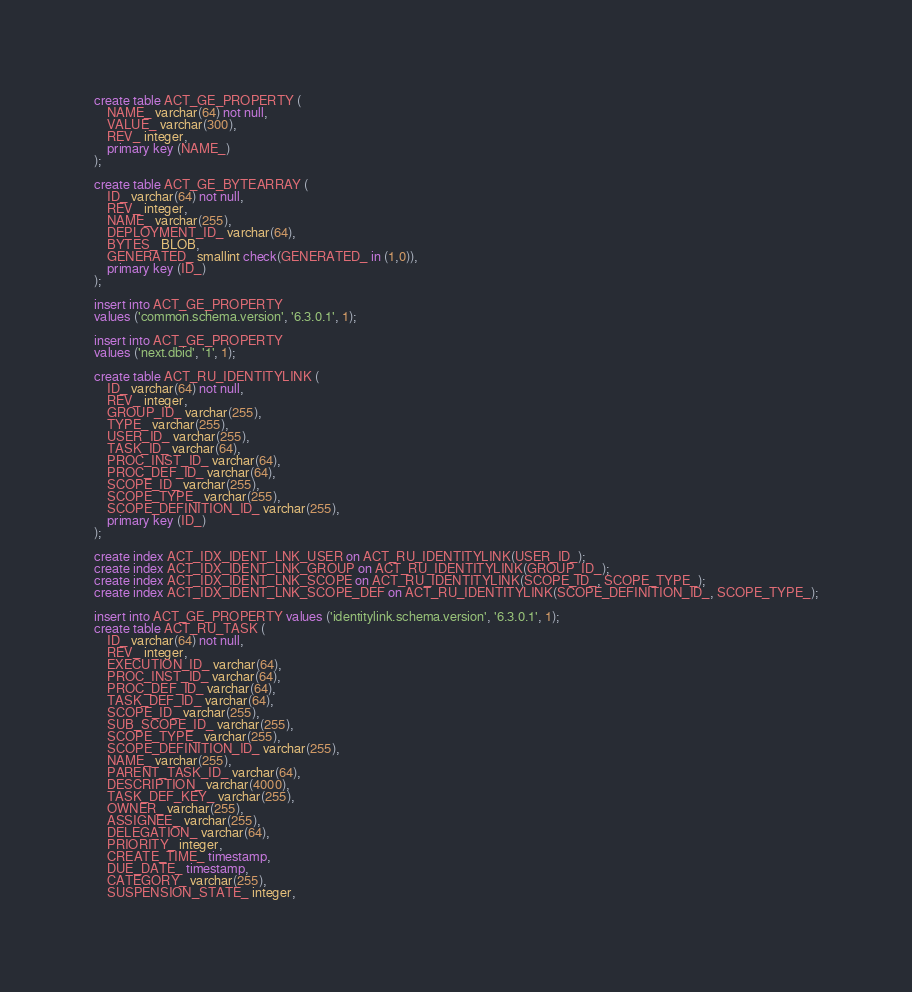Convert code to text. <code><loc_0><loc_0><loc_500><loc_500><_SQL_>create table ACT_GE_PROPERTY (
    NAME_ varchar(64) not null,
    VALUE_ varchar(300),
    REV_ integer,
    primary key (NAME_)
);

create table ACT_GE_BYTEARRAY (
    ID_ varchar(64) not null,
    REV_ integer,
    NAME_ varchar(255),
    DEPLOYMENT_ID_ varchar(64),
    BYTES_ BLOB,
    GENERATED_ smallint check(GENERATED_ in (1,0)),
    primary key (ID_)
);

insert into ACT_GE_PROPERTY
values ('common.schema.version', '6.3.0.1', 1);

insert into ACT_GE_PROPERTY
values ('next.dbid', '1', 1);

create table ACT_RU_IDENTITYLINK (
    ID_ varchar(64) not null,
    REV_ integer,
    GROUP_ID_ varchar(255),
    TYPE_ varchar(255),
    USER_ID_ varchar(255),
    TASK_ID_ varchar(64),
    PROC_INST_ID_ varchar(64),
    PROC_DEF_ID_ varchar(64),
    SCOPE_ID_ varchar(255),
    SCOPE_TYPE_ varchar(255),
    SCOPE_DEFINITION_ID_ varchar(255),
    primary key (ID_)
);

create index ACT_IDX_IDENT_LNK_USER on ACT_RU_IDENTITYLINK(USER_ID_);
create index ACT_IDX_IDENT_LNK_GROUP on ACT_RU_IDENTITYLINK(GROUP_ID_);
create index ACT_IDX_IDENT_LNK_SCOPE on ACT_RU_IDENTITYLINK(SCOPE_ID_, SCOPE_TYPE_);
create index ACT_IDX_IDENT_LNK_SCOPE_DEF on ACT_RU_IDENTITYLINK(SCOPE_DEFINITION_ID_, SCOPE_TYPE_);

insert into ACT_GE_PROPERTY values ('identitylink.schema.version', '6.3.0.1', 1);
create table ACT_RU_TASK (
    ID_ varchar(64) not null,
    REV_ integer,
    EXECUTION_ID_ varchar(64),
    PROC_INST_ID_ varchar(64),
    PROC_DEF_ID_ varchar(64),
    TASK_DEF_ID_ varchar(64),
    SCOPE_ID_ varchar(255),
    SUB_SCOPE_ID_ varchar(255),
    SCOPE_TYPE_ varchar(255),
    SCOPE_DEFINITION_ID_ varchar(255),
    NAME_ varchar(255),
    PARENT_TASK_ID_ varchar(64),
    DESCRIPTION_ varchar(4000),
    TASK_DEF_KEY_ varchar(255),
    OWNER_ varchar(255),
    ASSIGNEE_ varchar(255),
    DELEGATION_ varchar(64),
    PRIORITY_ integer,
    CREATE_TIME_ timestamp,
    DUE_DATE_ timestamp,
    CATEGORY_ varchar(255),
    SUSPENSION_STATE_ integer,</code> 